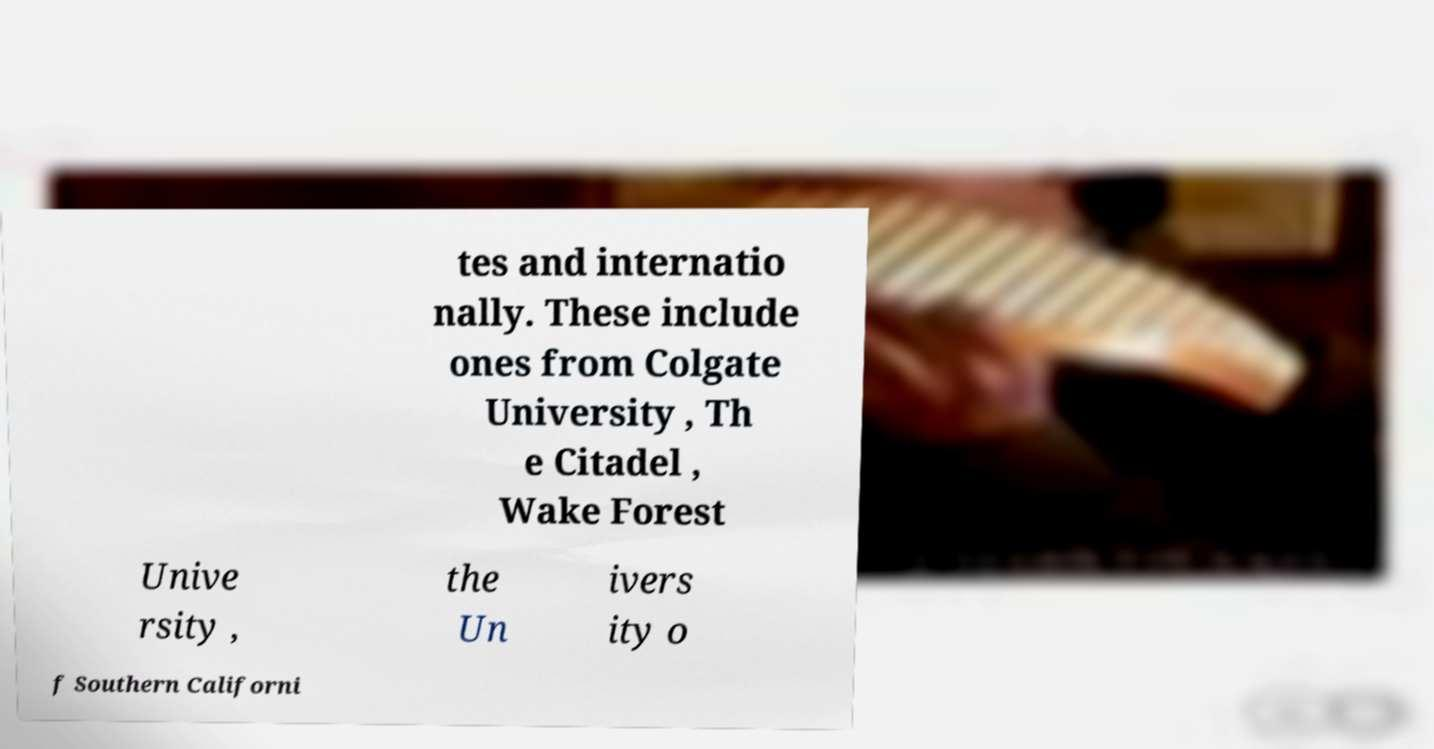Please identify and transcribe the text found in this image. tes and internatio nally. These include ones from Colgate University , Th e Citadel , Wake Forest Unive rsity , the Un ivers ity o f Southern Californi 